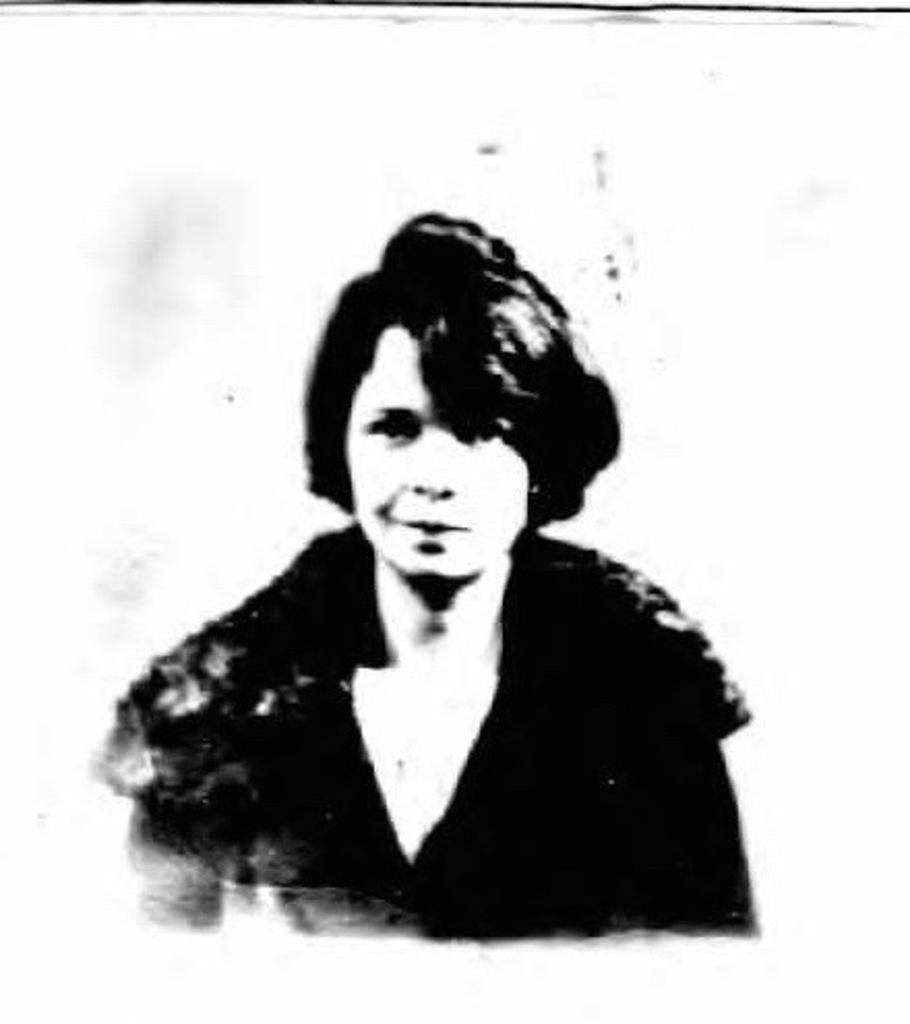What is the main subject of the image? There is a photo in the image. Who or what is depicted in the photo? There is a person in the photo. What color is the background of the photo? The background of the photo is white. How many rabbits are visible in the photo? There are no rabbits present in the image or the photo. What type of arithmetic problem is being solved in the photo? There is no arithmetic problem visible in the photo; it only depicts a person. 